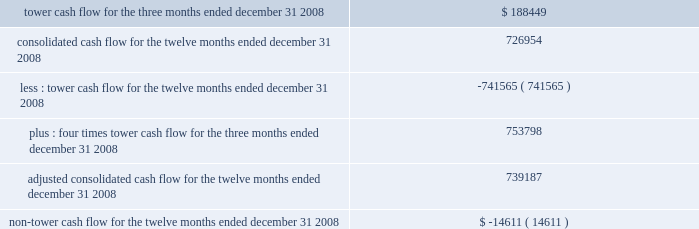Tower cash flow , adjusted consolidated cash flow and non-tower cash flow are considered non-gaap financial measures .
We are required to provide these financial metrics by the indentures for our 7.50% ( 7.50 % ) notes and 7.125% ( 7.125 % ) notes , and we have included them below because we consider the indentures for these notes to be material agreements , the covenants related to tower cash flow , adjusted consolidated cash flow and non-tower cash flow to be material terms of the indentures , and information about compliance with such covenants to be material to an investor 2019s understanding of our financial results and the impact of those results on our liquidity .
The table presents tower cash flow , adjusted consolidated cash flow and non-tower cash flow for the company and its restricted subsidiaries , as defined in the indentures for the applicable notes ( in thousands ) : .

What portion of the adjusted consolidated cash flow for the twelve months ended december 31 , 2008 is related to non-tower cash flow? 
Computations: (-14611 / 739187)
Answer: -0.01977. Tower cash flow , adjusted consolidated cash flow and non-tower cash flow are considered non-gaap financial measures .
We are required to provide these financial metrics by the indentures for our 7.50% ( 7.50 % ) notes and 7.125% ( 7.125 % ) notes , and we have included them below because we consider the indentures for these notes to be material agreements , the covenants related to tower cash flow , adjusted consolidated cash flow and non-tower cash flow to be material terms of the indentures , and information about compliance with such covenants to be material to an investor 2019s understanding of our financial results and the impact of those results on our liquidity .
The table presents tower cash flow , adjusted consolidated cash flow and non-tower cash flow for the company and its restricted subsidiaries , as defined in the indentures for the applicable notes ( in thousands ) : .

What portion of the adjusted consolidated cash flow for the twelve months ended december 31 , 2008 is related to tower cash flow? 
Computations: (753798 / 739187)
Answer: 1.01977. Tower cash flow , adjusted consolidated cash flow and non-tower cash flow are considered non-gaap financial measures .
We are required to provide these financial metrics by the indentures for our 7.50% ( 7.50 % ) notes and 7.125% ( 7.125 % ) notes , and we have included them below because we consider the indentures for these notes to be material agreements , the covenants related to tower cash flow , adjusted consolidated cash flow and non-tower cash flow to be material terms of the indentures , and information about compliance with such covenants to be material to an investor 2019s understanding of our financial results and the impact of those results on our liquidity .
The table presents tower cash flow , adjusted consolidated cash flow and non-tower cash flow for the company and its restricted subsidiaries , as defined in the indentures for the applicable notes ( in thousands ) : .

What was the average tower cash flow for the three months ended december 31 2008? 
Computations: (188449 / 3)
Answer: 62816.33333. 